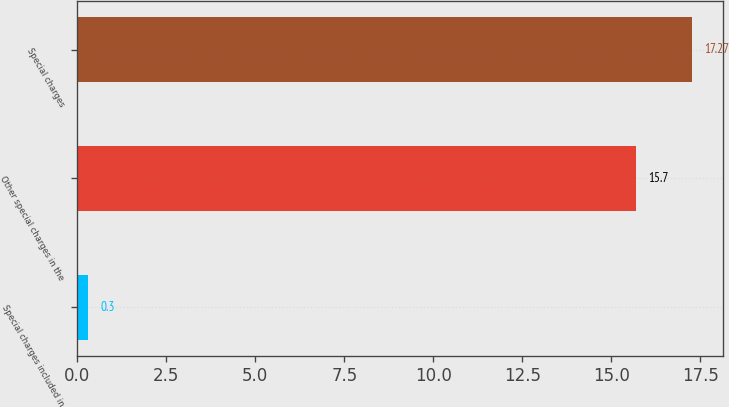Convert chart. <chart><loc_0><loc_0><loc_500><loc_500><bar_chart><fcel>Special charges included in<fcel>Other special charges in the<fcel>Special charges<nl><fcel>0.3<fcel>15.7<fcel>17.27<nl></chart> 